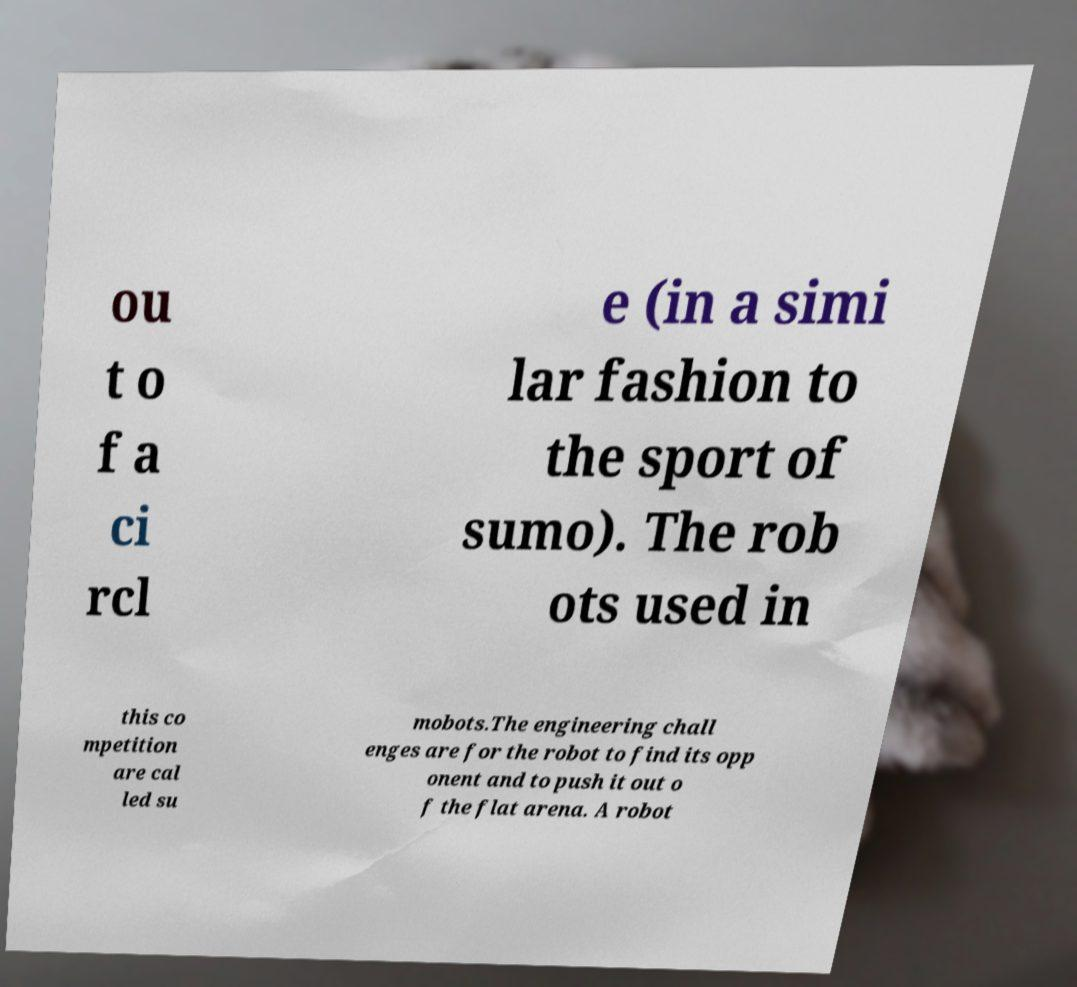Could you extract and type out the text from this image? ou t o f a ci rcl e (in a simi lar fashion to the sport of sumo). The rob ots used in this co mpetition are cal led su mobots.The engineering chall enges are for the robot to find its opp onent and to push it out o f the flat arena. A robot 